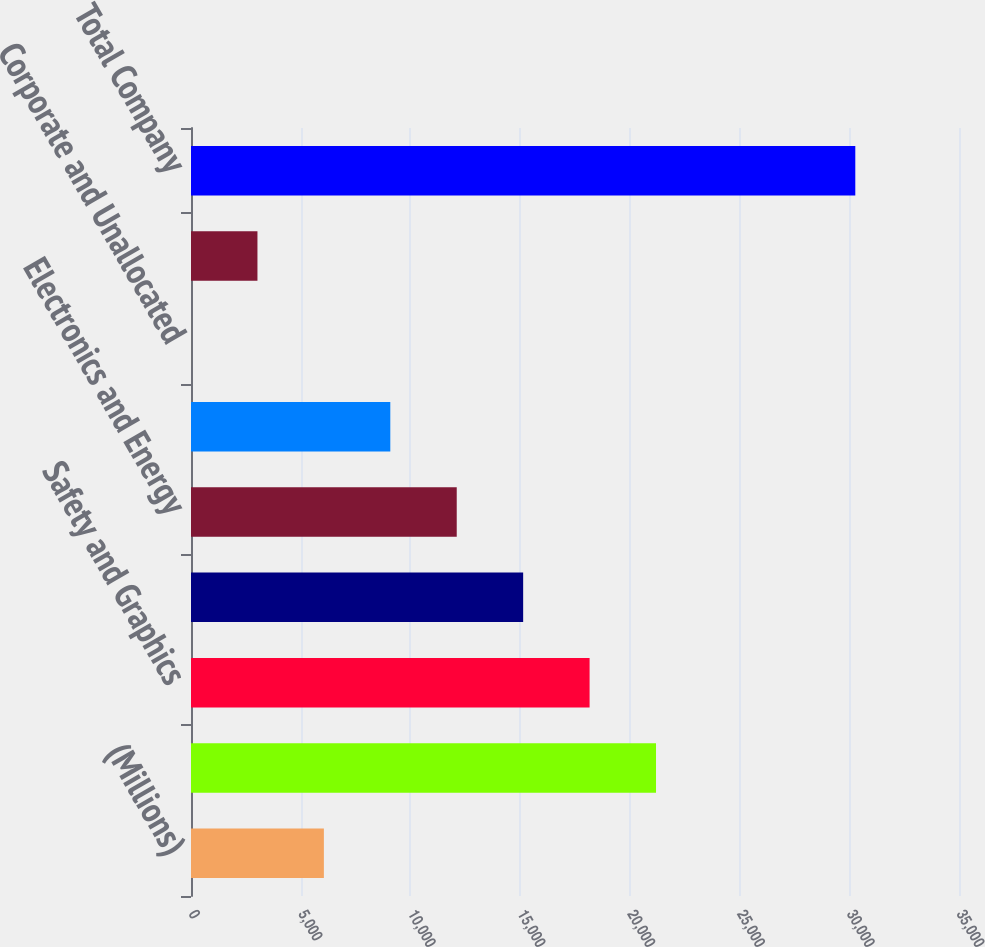Convert chart to OTSL. <chart><loc_0><loc_0><loc_500><loc_500><bar_chart><fcel>(Millions)<fcel>Industrial<fcel>Safety and Graphics<fcel>Health Care<fcel>Electronics and Energy<fcel>Consumer<fcel>Corporate and Unallocated<fcel>Elimination of Dual Credit<fcel>Total Company<nl><fcel>6055.6<fcel>21192.1<fcel>18164.8<fcel>15137.5<fcel>12110.2<fcel>9082.9<fcel>1<fcel>3028.3<fcel>30274<nl></chart> 